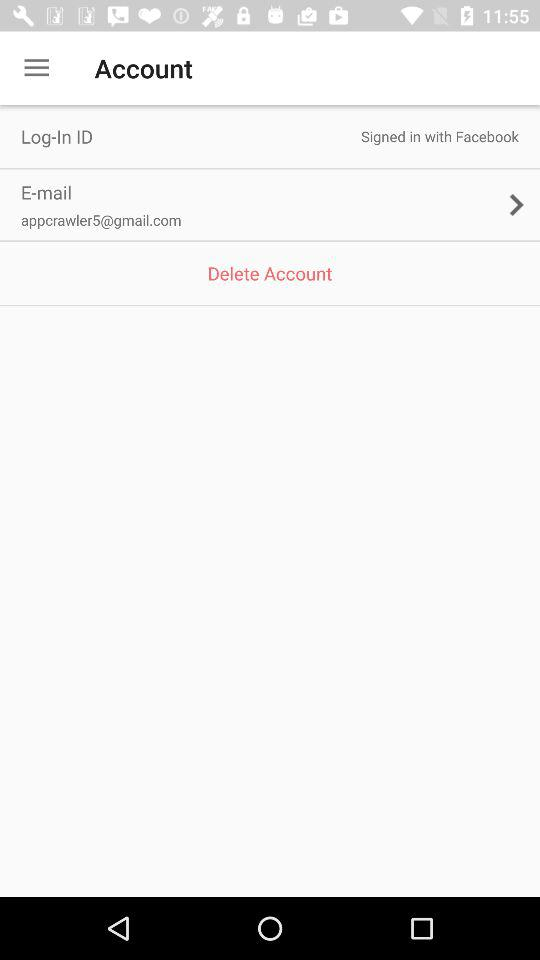What is the email address? The email address is appcrawler5@gmail.com. 